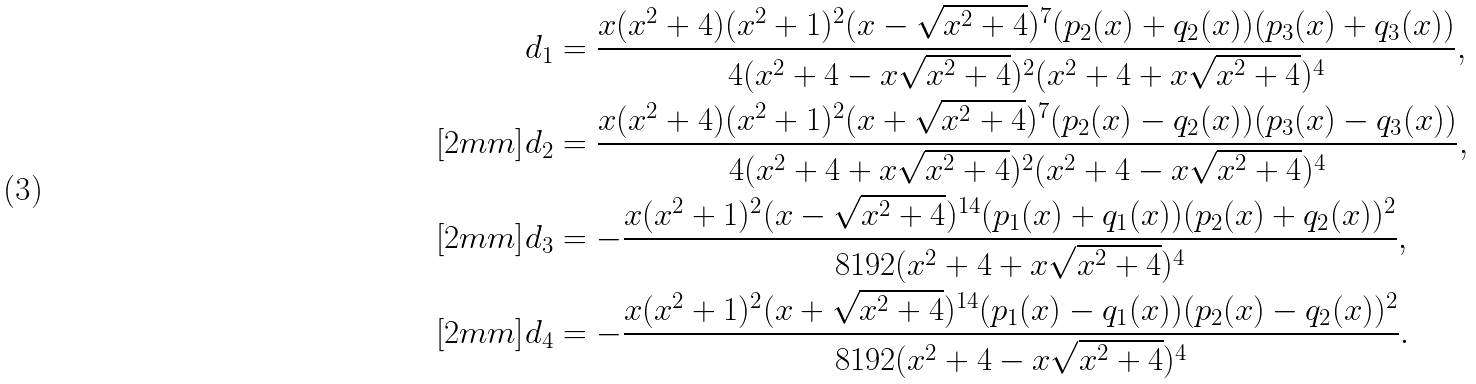<formula> <loc_0><loc_0><loc_500><loc_500>& d _ { 1 } = \frac { x ( x ^ { 2 } + 4 ) ( x ^ { 2 } + 1 ) ^ { 2 } ( x - \sqrt { x ^ { 2 } + 4 } ) ^ { 7 } ( p _ { 2 } ( x ) + q _ { 2 } ( x ) ) ( p _ { 3 } ( x ) + q _ { 3 } ( x ) ) } { 4 ( x ^ { 2 } + 4 - x \sqrt { x ^ { 2 } + 4 } ) ^ { 2 } ( x ^ { 2 } + 4 + x \sqrt { x ^ { 2 } + 4 } ) ^ { 4 } } , \\ [ 2 m m ] & d _ { 2 } = \frac { x ( x ^ { 2 } + 4 ) ( x ^ { 2 } + 1 ) ^ { 2 } ( x + \sqrt { x ^ { 2 } + 4 } ) ^ { 7 } ( p _ { 2 } ( x ) - q _ { 2 } ( x ) ) ( p _ { 3 } ( x ) - q _ { 3 } ( x ) ) } { 4 ( x ^ { 2 } + 4 + x \sqrt { x ^ { 2 } + 4 } ) ^ { 2 } ( x ^ { 2 } + 4 - x \sqrt { x ^ { 2 } + 4 } ) ^ { 4 } } , \\ [ 2 m m ] & d _ { 3 } = - \frac { x ( x ^ { 2 } + 1 ) ^ { 2 } ( x - \sqrt { x ^ { 2 } + 4 } ) ^ { 1 4 } ( p _ { 1 } ( x ) + q _ { 1 } ( x ) ) ( p _ { 2 } ( x ) + q _ { 2 } ( x ) ) ^ { 2 } } { 8 1 9 2 ( x ^ { 2 } + 4 + x \sqrt { x ^ { 2 } + 4 } ) ^ { 4 } } , \\ [ 2 m m ] & d _ { 4 } = - \frac { x ( x ^ { 2 } + 1 ) ^ { 2 } ( x + \sqrt { x ^ { 2 } + 4 } ) ^ { 1 4 } ( p _ { 1 } ( x ) - q _ { 1 } ( x ) ) ( p _ { 2 } ( x ) - q _ { 2 } ( x ) ) ^ { 2 } } { 8 1 9 2 ( x ^ { 2 } + 4 - x \sqrt { x ^ { 2 } + 4 } ) ^ { 4 } } .</formula> 